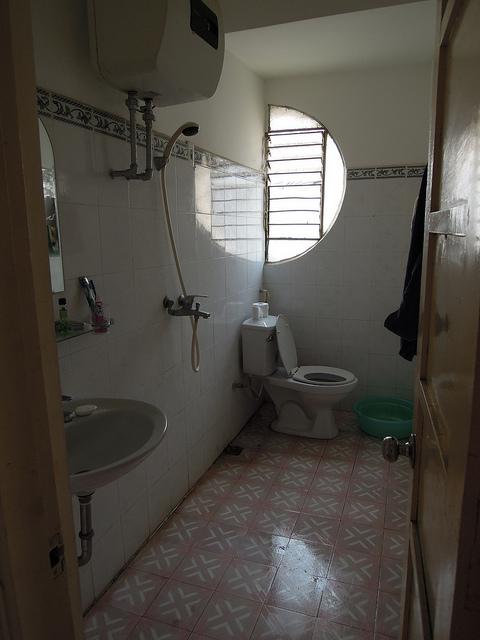What is the name of this room?
Keep it brief. Bathroom. Is this a man or woman's bathroom?
Quick response, please. Both. What color is the bin on the floor?
Be succinct. Green. Is this the dining room?
Concise answer only. No. Is the light on?
Concise answer only. No. 